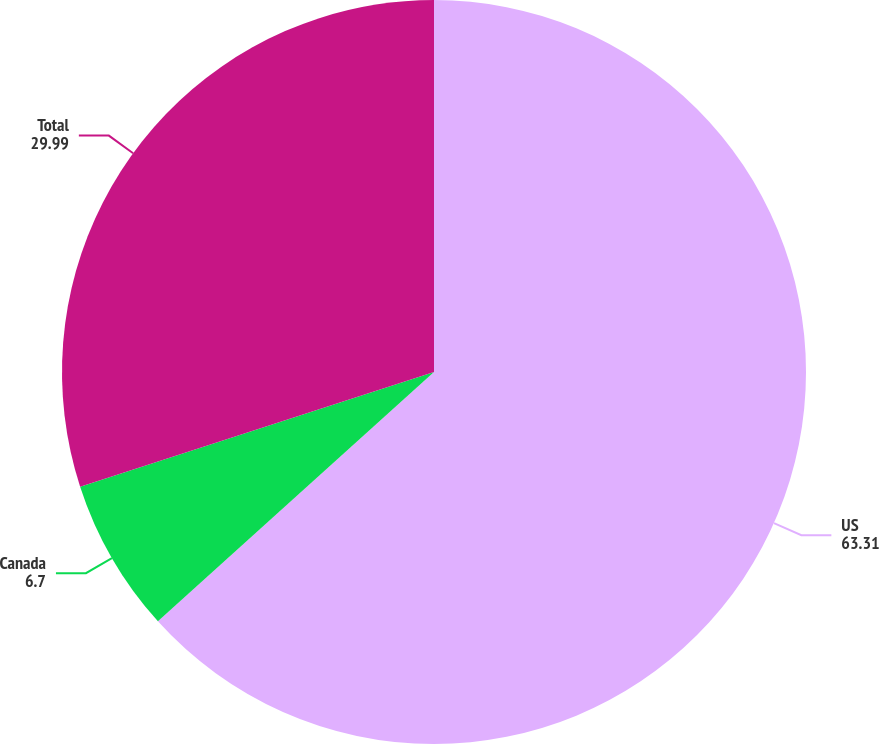Convert chart. <chart><loc_0><loc_0><loc_500><loc_500><pie_chart><fcel>US<fcel>Canada<fcel>Total<nl><fcel>63.31%<fcel>6.7%<fcel>29.99%<nl></chart> 